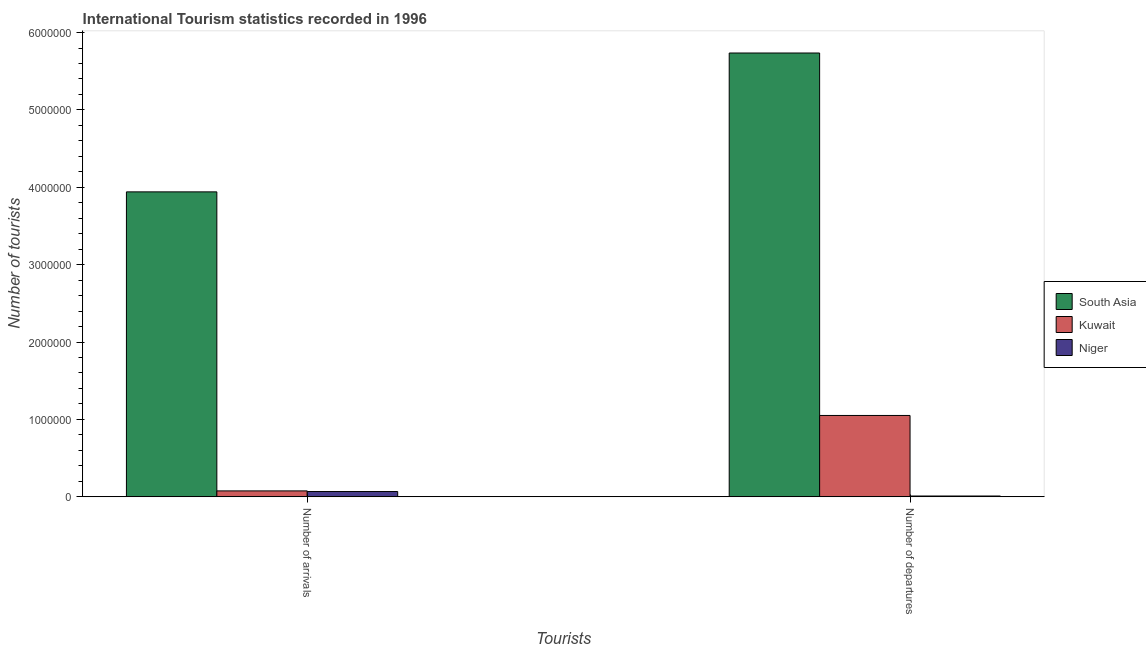How many different coloured bars are there?
Give a very brief answer. 3. Are the number of bars per tick equal to the number of legend labels?
Keep it short and to the point. Yes. Are the number of bars on each tick of the X-axis equal?
Ensure brevity in your answer.  Yes. How many bars are there on the 1st tick from the right?
Your response must be concise. 3. What is the label of the 2nd group of bars from the left?
Provide a succinct answer. Number of departures. What is the number of tourist departures in Niger?
Your answer should be compact. 10000. Across all countries, what is the maximum number of tourist departures?
Your answer should be very brief. 5.74e+06. Across all countries, what is the minimum number of tourist arrivals?
Your answer should be compact. 6.80e+04. In which country was the number of tourist arrivals maximum?
Give a very brief answer. South Asia. In which country was the number of tourist arrivals minimum?
Provide a short and direct response. Niger. What is the total number of tourist departures in the graph?
Your answer should be very brief. 6.80e+06. What is the difference between the number of tourist arrivals in Kuwait and that in South Asia?
Your response must be concise. -3.86e+06. What is the difference between the number of tourist arrivals in South Asia and the number of tourist departures in Kuwait?
Offer a terse response. 2.89e+06. What is the average number of tourist departures per country?
Ensure brevity in your answer.  2.27e+06. What is the difference between the number of tourist departures and number of tourist arrivals in Kuwait?
Your answer should be compact. 9.75e+05. In how many countries, is the number of tourist arrivals greater than 3000000 ?
Your answer should be compact. 1. What is the ratio of the number of tourist arrivals in Kuwait to that in South Asia?
Provide a short and direct response. 0.02. In how many countries, is the number of tourist departures greater than the average number of tourist departures taken over all countries?
Offer a very short reply. 1. What does the 3rd bar from the left in Number of departures represents?
Your answer should be very brief. Niger. What does the 2nd bar from the right in Number of departures represents?
Give a very brief answer. Kuwait. What is the difference between two consecutive major ticks on the Y-axis?
Your answer should be very brief. 1.00e+06. Are the values on the major ticks of Y-axis written in scientific E-notation?
Provide a succinct answer. No. Does the graph contain any zero values?
Give a very brief answer. No. Does the graph contain grids?
Ensure brevity in your answer.  No. How many legend labels are there?
Ensure brevity in your answer.  3. What is the title of the graph?
Keep it short and to the point. International Tourism statistics recorded in 1996. Does "Cuba" appear as one of the legend labels in the graph?
Your response must be concise. No. What is the label or title of the X-axis?
Offer a terse response. Tourists. What is the label or title of the Y-axis?
Offer a very short reply. Number of tourists. What is the Number of tourists in South Asia in Number of arrivals?
Give a very brief answer. 3.94e+06. What is the Number of tourists in Kuwait in Number of arrivals?
Give a very brief answer. 7.60e+04. What is the Number of tourists of Niger in Number of arrivals?
Your answer should be compact. 6.80e+04. What is the Number of tourists of South Asia in Number of departures?
Your answer should be very brief. 5.74e+06. What is the Number of tourists of Kuwait in Number of departures?
Your answer should be very brief. 1.05e+06. Across all Tourists, what is the maximum Number of tourists in South Asia?
Make the answer very short. 5.74e+06. Across all Tourists, what is the maximum Number of tourists in Kuwait?
Ensure brevity in your answer.  1.05e+06. Across all Tourists, what is the maximum Number of tourists in Niger?
Provide a succinct answer. 6.80e+04. Across all Tourists, what is the minimum Number of tourists of South Asia?
Offer a very short reply. 3.94e+06. Across all Tourists, what is the minimum Number of tourists of Kuwait?
Give a very brief answer. 7.60e+04. What is the total Number of tourists in South Asia in the graph?
Your response must be concise. 9.68e+06. What is the total Number of tourists of Kuwait in the graph?
Ensure brevity in your answer.  1.13e+06. What is the total Number of tourists in Niger in the graph?
Provide a short and direct response. 7.80e+04. What is the difference between the Number of tourists of South Asia in Number of arrivals and that in Number of departures?
Keep it short and to the point. -1.79e+06. What is the difference between the Number of tourists in Kuwait in Number of arrivals and that in Number of departures?
Ensure brevity in your answer.  -9.75e+05. What is the difference between the Number of tourists of Niger in Number of arrivals and that in Number of departures?
Ensure brevity in your answer.  5.80e+04. What is the difference between the Number of tourists of South Asia in Number of arrivals and the Number of tourists of Kuwait in Number of departures?
Offer a very short reply. 2.89e+06. What is the difference between the Number of tourists of South Asia in Number of arrivals and the Number of tourists of Niger in Number of departures?
Offer a terse response. 3.93e+06. What is the difference between the Number of tourists of Kuwait in Number of arrivals and the Number of tourists of Niger in Number of departures?
Ensure brevity in your answer.  6.60e+04. What is the average Number of tourists of South Asia per Tourists?
Ensure brevity in your answer.  4.84e+06. What is the average Number of tourists of Kuwait per Tourists?
Ensure brevity in your answer.  5.64e+05. What is the average Number of tourists in Niger per Tourists?
Keep it short and to the point. 3.90e+04. What is the difference between the Number of tourists in South Asia and Number of tourists in Kuwait in Number of arrivals?
Keep it short and to the point. 3.86e+06. What is the difference between the Number of tourists of South Asia and Number of tourists of Niger in Number of arrivals?
Your answer should be very brief. 3.87e+06. What is the difference between the Number of tourists of Kuwait and Number of tourists of Niger in Number of arrivals?
Keep it short and to the point. 8000. What is the difference between the Number of tourists of South Asia and Number of tourists of Kuwait in Number of departures?
Keep it short and to the point. 4.68e+06. What is the difference between the Number of tourists in South Asia and Number of tourists in Niger in Number of departures?
Your answer should be very brief. 5.73e+06. What is the difference between the Number of tourists of Kuwait and Number of tourists of Niger in Number of departures?
Your response must be concise. 1.04e+06. What is the ratio of the Number of tourists in South Asia in Number of arrivals to that in Number of departures?
Ensure brevity in your answer.  0.69. What is the ratio of the Number of tourists of Kuwait in Number of arrivals to that in Number of departures?
Offer a very short reply. 0.07. What is the ratio of the Number of tourists of Niger in Number of arrivals to that in Number of departures?
Your answer should be compact. 6.8. What is the difference between the highest and the second highest Number of tourists in South Asia?
Ensure brevity in your answer.  1.79e+06. What is the difference between the highest and the second highest Number of tourists in Kuwait?
Give a very brief answer. 9.75e+05. What is the difference between the highest and the second highest Number of tourists in Niger?
Make the answer very short. 5.80e+04. What is the difference between the highest and the lowest Number of tourists in South Asia?
Provide a short and direct response. 1.79e+06. What is the difference between the highest and the lowest Number of tourists in Kuwait?
Provide a short and direct response. 9.75e+05. What is the difference between the highest and the lowest Number of tourists in Niger?
Your answer should be very brief. 5.80e+04. 